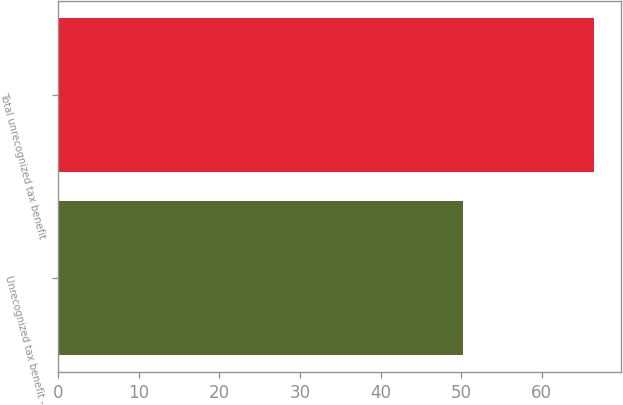Convert chart. <chart><loc_0><loc_0><loc_500><loc_500><bar_chart><fcel>Unrecognized tax benefit -<fcel>Total unrecognized tax benefit<nl><fcel>50.3<fcel>66.5<nl></chart> 